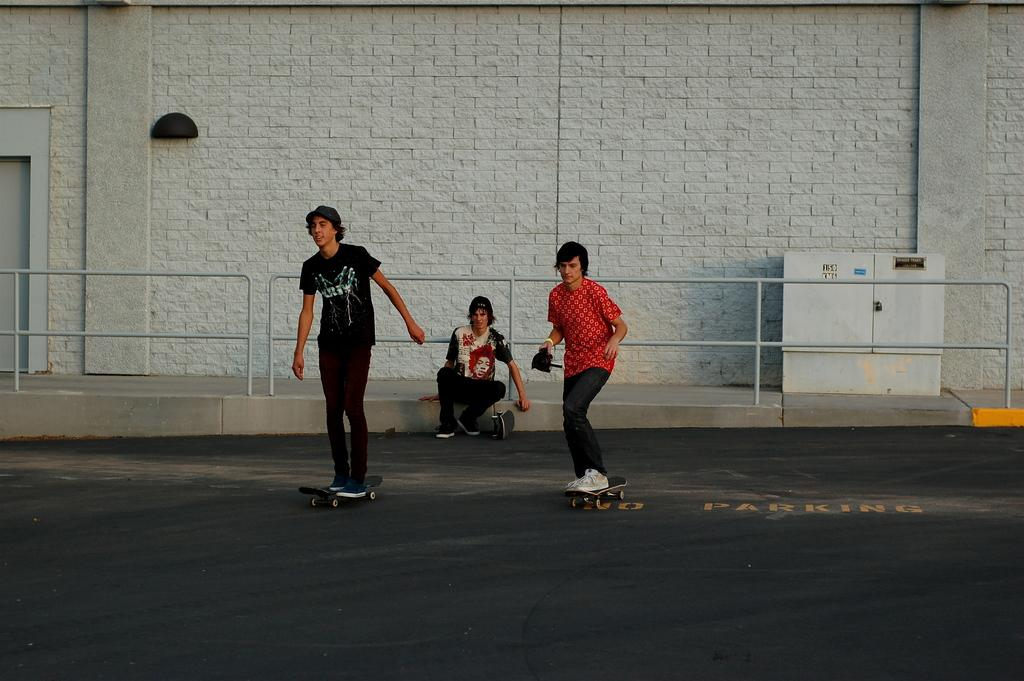What are the two persons in the image doing? The two persons are skating on skateboards. What is the position of the third person in the image? There is a person sitting in the middle. What can be seen in the background of the image? There is a wall in the background. What object is located on the right side of the image? There is a box on the right side. What type of cheese is being carried in the pocket of the person sitting in the middle? There is no cheese or pocket present in the image. How many turkeys can be seen in the image? There are no turkeys present in the image. 